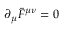<formula> <loc_0><loc_0><loc_500><loc_500>\partial _ { \mu } \widetilde { F } ^ { \mu \nu } = 0</formula> 